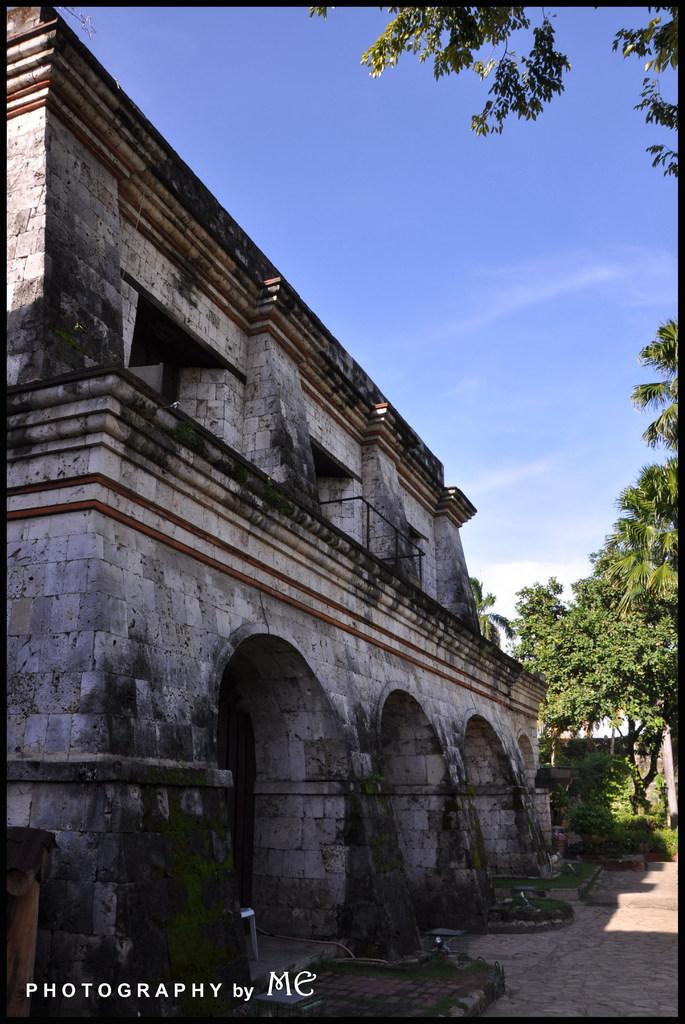What type of structure is visible in the image? There is a building in the image. What other elements can be seen in the image besides the building? There are trees in the image. Where is the tray located in the image? There is no tray present in the image. What route does the person take to reach the bedroom in the image? There is no person or bedroom present in the image. 